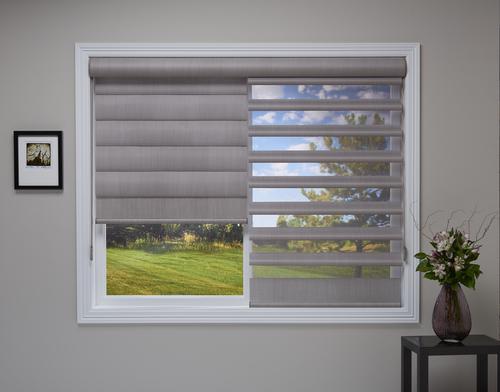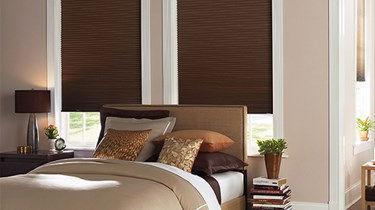The first image is the image on the left, the second image is the image on the right. For the images shown, is this caption "In the image to the left, the slats of the window shade are not completely closed; you can still see a little bit of light." true? Answer yes or no. Yes. 